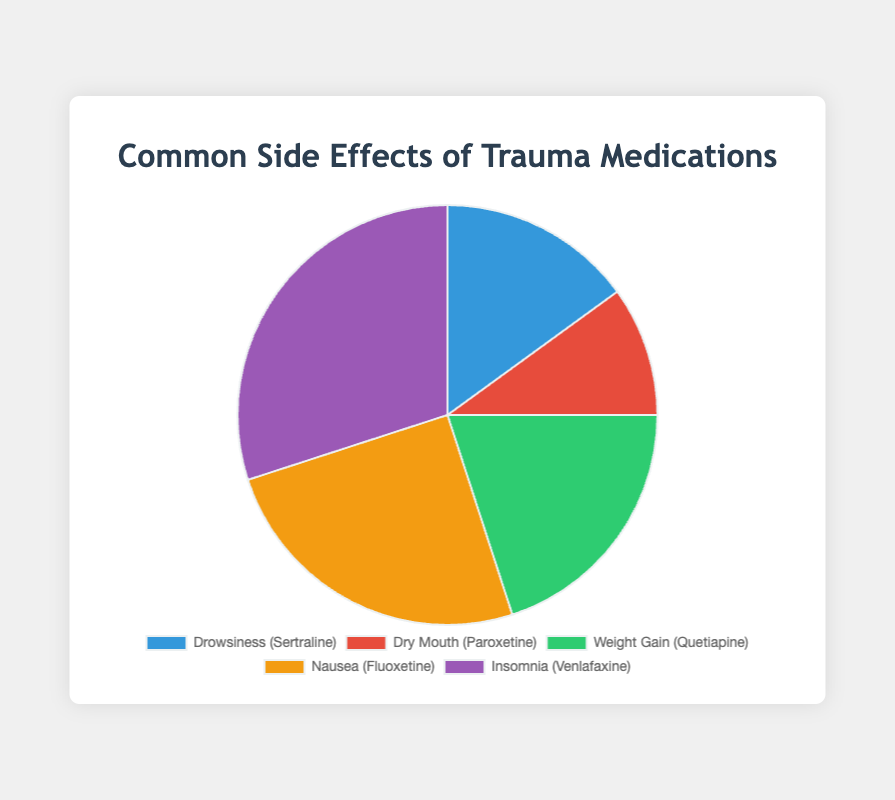What is the most prevalent side effect shown in the pie chart? To determine the most prevalent side effect, look for the segment with the highest percentage. In the pie chart, 'Insomnia (Venlafaxine)' has the highest percentage at 30%.
Answer: Insomnia How much more prevalent is nausea compared to dry mouth? Nausea has a prevalence of 25%, while dry mouth has a prevalence of 10%. The difference in prevalence is 25% - 10% = 15%.
Answer: 15% What is the combined prevalence percentage of drowsiness and weight gain? Add the prevalence percentages of drowsiness and weight gain: 15% (drowsiness) + 20% (weight gain) = 35%.
Answer: 35% Which two side effects together account for exactly half of the total prevalence? Adding the percentages of the side effects, we find 'Nausea (25%)' and 'Insomnia (30%)' together account for more than half. Check other combinations and find that 'Weight Gain (20%)' and 'Insomnia (30%)' equal 50%.
Answer: Weight Gain and Insomnia Is dry mouth more prevalent or less prevalent than drowsiness? Compare the percentages: dry mouth is 10% and drowsiness is 15%. Dry mouth is less prevalent than drowsiness.
Answer: Less prevalent What color represents weight gain in the pie chart? Observing the legend or color coding in the pie chart reveals that weight gain is represented by green.
Answer: Green By how much does the prevalence of insomnia exceed the combined prevalence of dry mouth and drowsiness? The combined prevalence of dry mouth and drowsiness is 10% + 15% = 25%. Insomnia's prevalence is 30%, so the difference is 30% - 25% = 5%.
Answer: 5% What side effect is represented by the purple segment in the chart? Checking the color coding of the segments, purple represents nausea.
Answer: Nausea What is the average prevalence percentage of all the side effects listed? Sum all the percentages: 15% + 10% + 20% + 25% + 30% = 100%. Calculate the average: 100% / 5 side effects = 20%.
Answer: 20% 